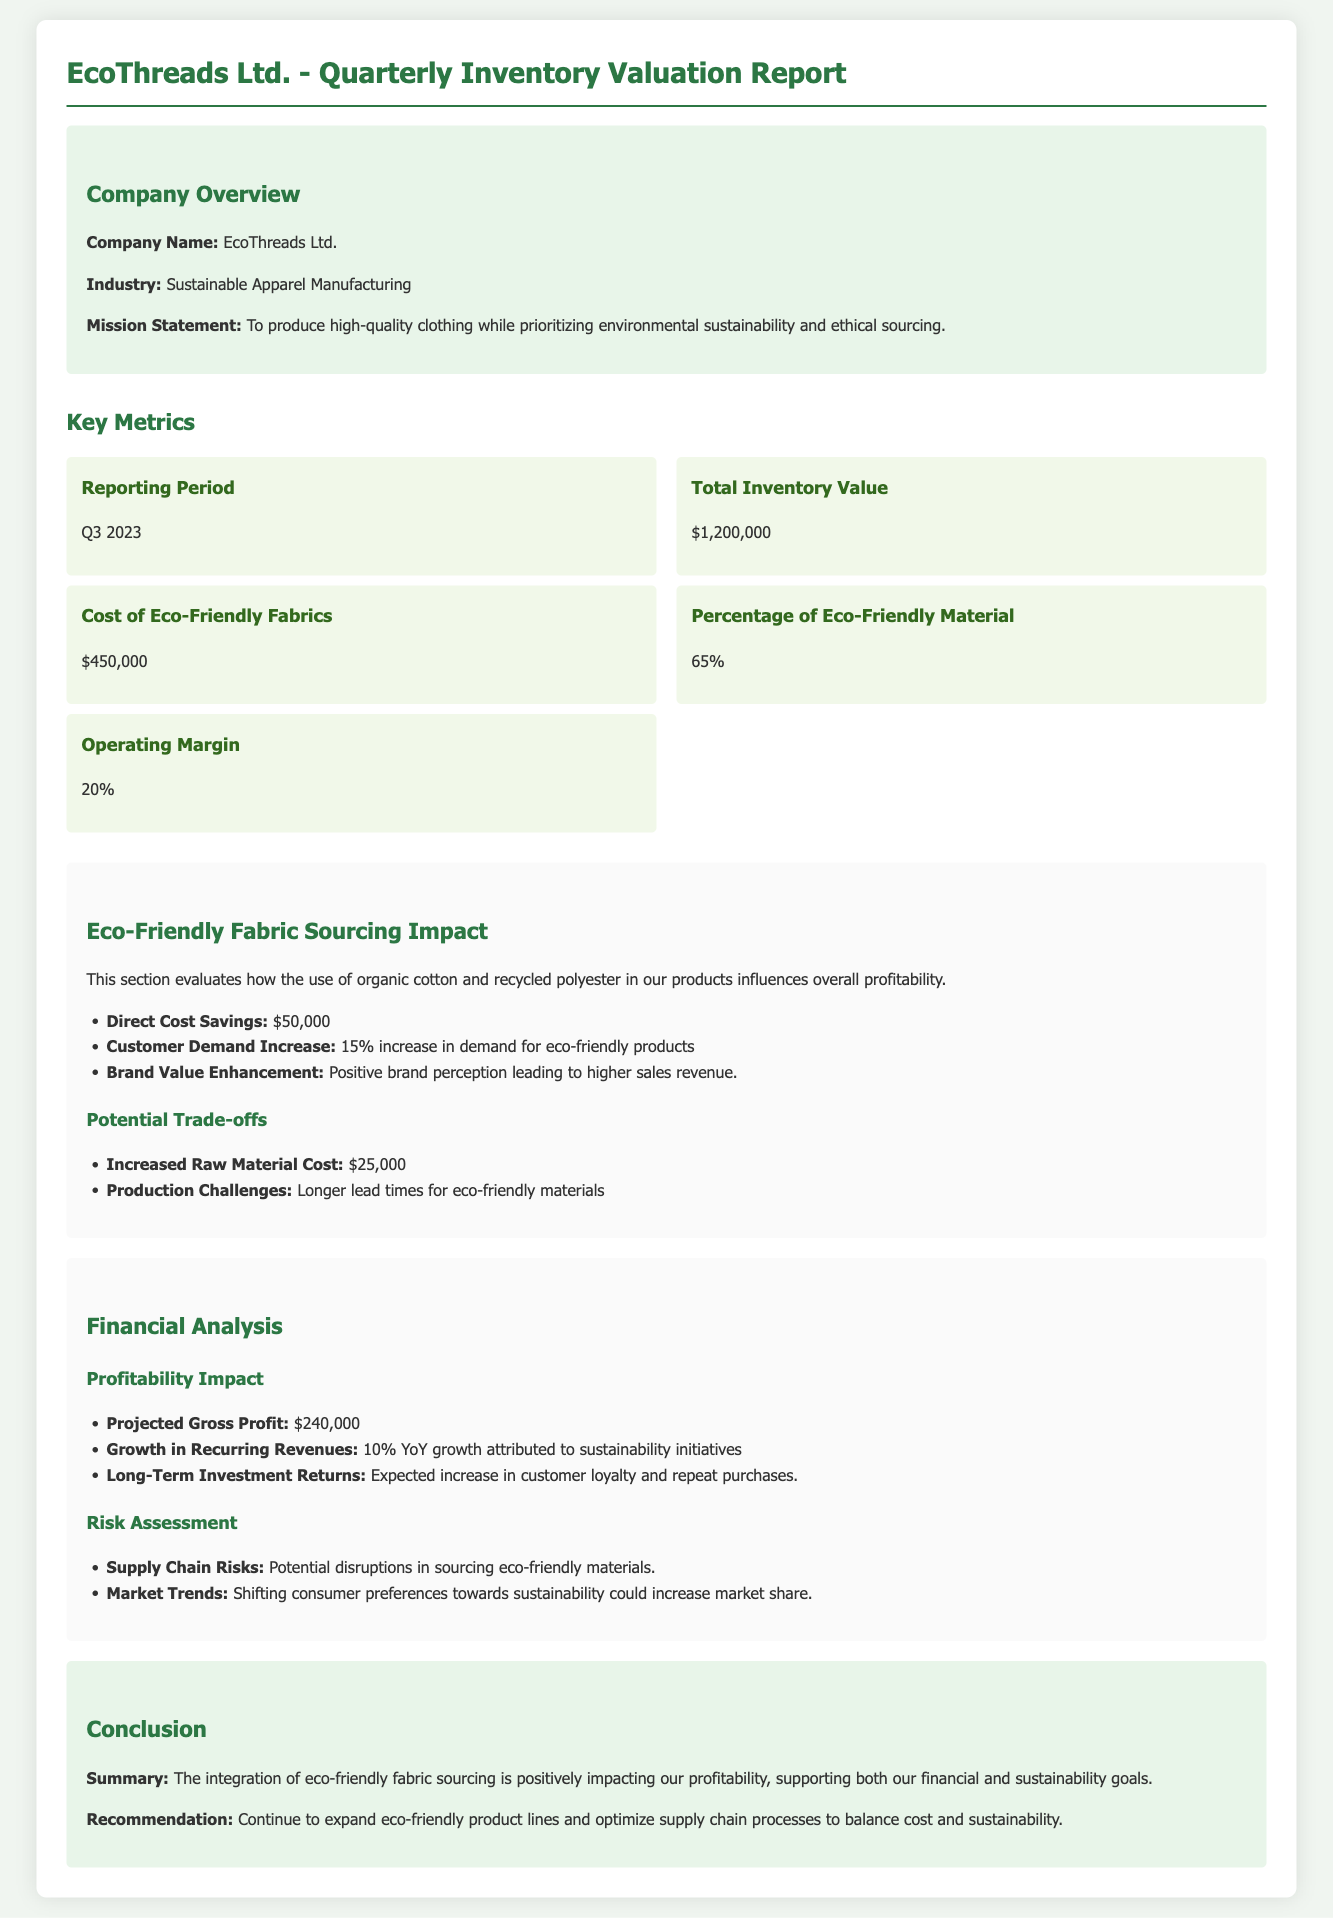What is the total inventory value? The total inventory value is stated directly in the document as $1,200,000.
Answer: $1,200,000 What percentage of eco-friendly material is used? The percentage of eco-friendly material is provided as 65% in the key metrics section of the document.
Answer: 65% What is the cost of eco-friendly fabrics? The document specifies that the cost of eco-friendly fabrics is $450,000.
Answer: $450,000 What is the projected gross profit? The projected gross profit of the company is mentioned as $240,000 in the financial analysis section.
Answer: $240,000 What is the increase in customer demand for eco-friendly products? An increase in demand for eco-friendly products is noted as a 15% increase in the impact analysis section.
Answer: 15% What is the direct cost savings from eco-friendly fabric sourcing? The direct cost savings from eco-friendly fabric sourcing are stated as $50,000 in the impact analysis.
Answer: $50,000 What are the risks associated with eco-friendly fabric sourcing? Supply chain risks and market trends are specifically mentioned as risks in the document.
Answer: Supply chain risks What is the operating margin reported? The operating margin is provided as 20% in the key metrics section.
Answer: 20% What is the expectation for long-term investment returns? The expectation is described as an increase in customer loyalty and repeat purchases.
Answer: Increase in customer loyalty 